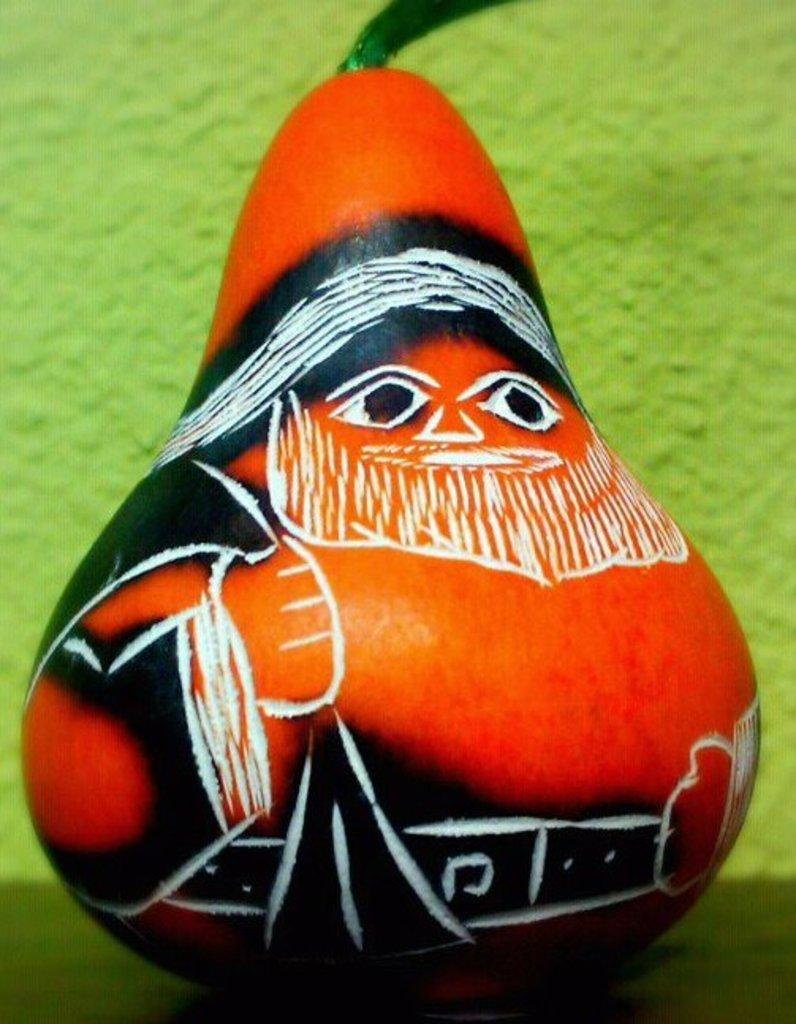What is on the pumpkin in the image? There is a painting on a pumpkin. What color is the pumpkin? The pumpkin is orange. What color is the background in the image? There is a green background. What type of fireman can be seen interacting with the fairies in the image? There are no firemen or fairies present in the image; it features a painted pumpkin with an orange color and a green background. 